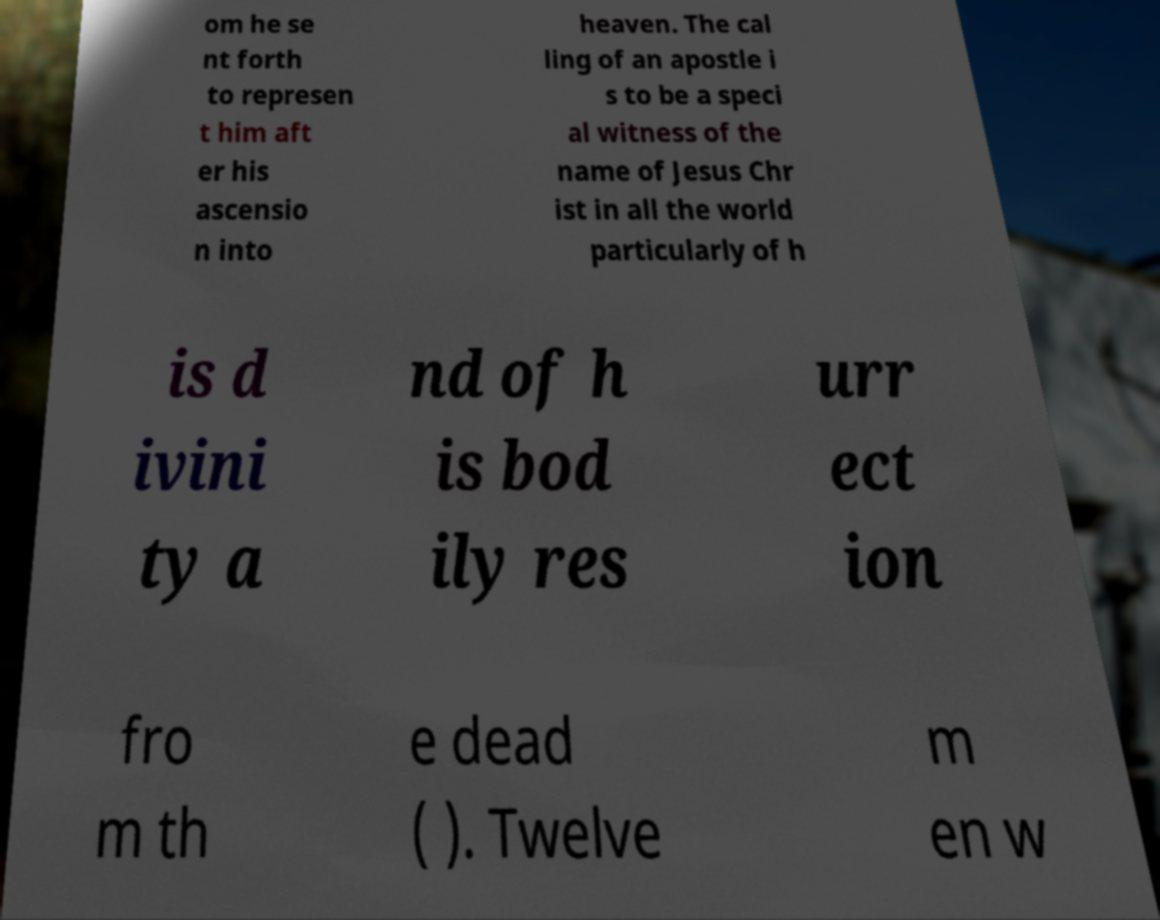Could you extract and type out the text from this image? om he se nt forth to represen t him aft er his ascensio n into heaven. The cal ling of an apostle i s to be a speci al witness of the name of Jesus Chr ist in all the world particularly of h is d ivini ty a nd of h is bod ily res urr ect ion fro m th e dead ( ). Twelve m en w 